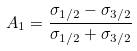<formula> <loc_0><loc_0><loc_500><loc_500>A _ { 1 } = \frac { \sigma _ { 1 / 2 } - \sigma _ { 3 / 2 } } { \sigma _ { 1 / 2 } + \sigma _ { 3 / 2 } }</formula> 